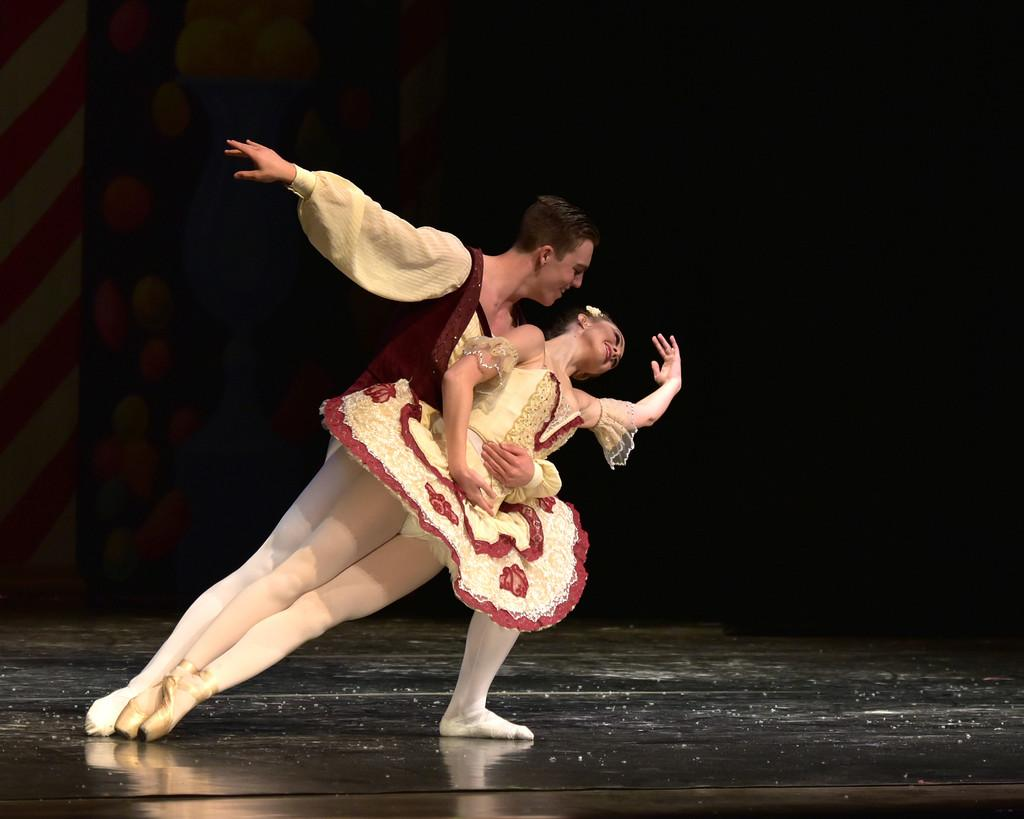What is the main subject of the image? There is a man in the image. Where is the man located in the image? The man is standing on a stage. What is the man doing in the image? The man is holding a woman. What can be seen in the background of the image? There is a wall in the background of the image. What type of juice is being prepared on the stove in the image? There is no stove or juice present in the image; it features a man standing on a stage holding a woman. Is the man in the image planning an attack on the woman? There is no indication in the image that the man is planning an attack on the woman; he is simply holding her. 